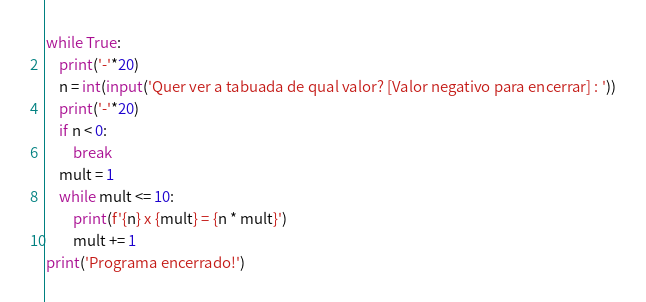<code> <loc_0><loc_0><loc_500><loc_500><_Python_>while True:
    print('-'*20)
    n = int(input('Quer ver a tabuada de qual valor? [Valor negativo para encerrar] : '))
    print('-'*20)
    if n < 0:
        break
    mult = 1
    while mult <= 10:
        print(f'{n} x {mult} = {n * mult}')
        mult += 1
print('Programa encerrado!')
</code> 